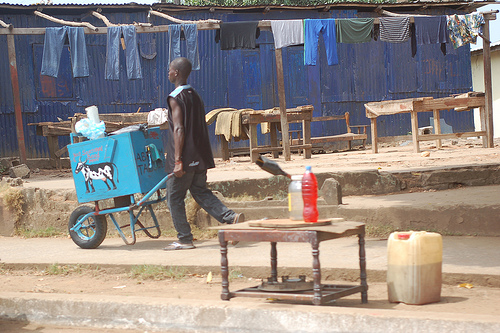<image>
Is there a soda bottle in the cart? No. The soda bottle is not contained within the cart. These objects have a different spatial relationship. Is there a pants above the ground? Yes. The pants is positioned above the ground in the vertical space, higher up in the scene. 